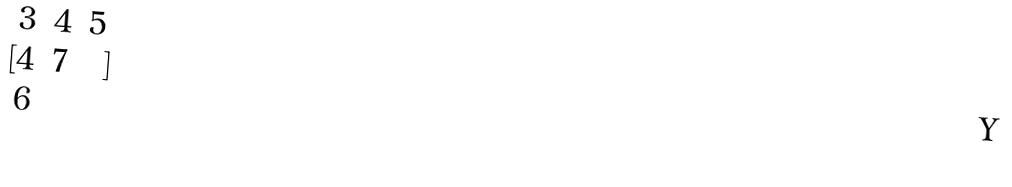<formula> <loc_0><loc_0><loc_500><loc_500>[ \begin{matrix} 3 & 4 & 5 \\ 4 & 7 \\ 6 \end{matrix} ]</formula> 